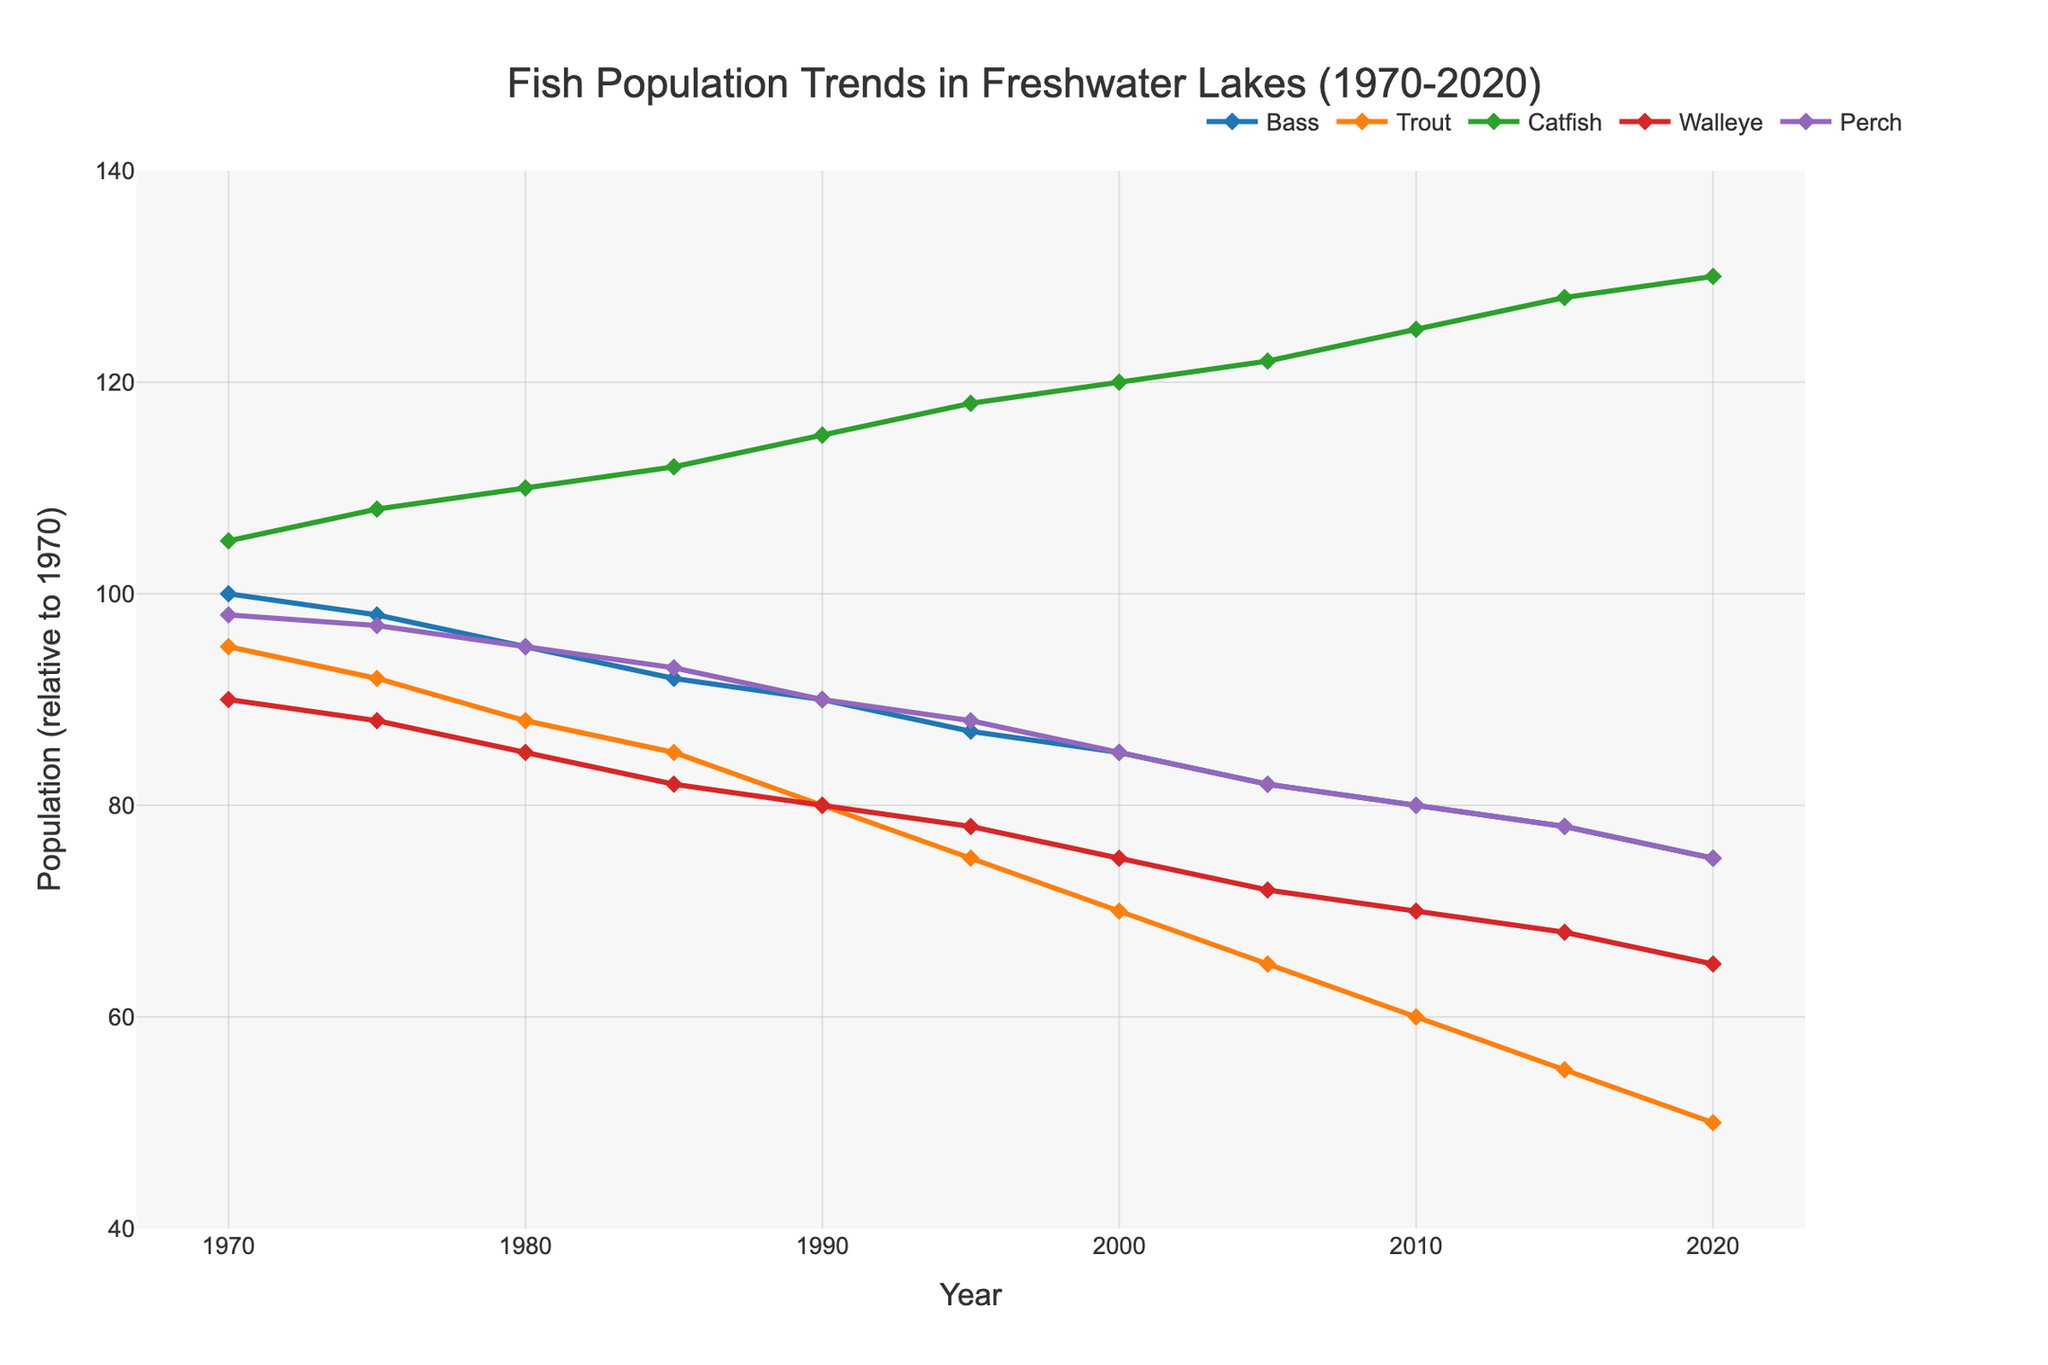How has the Bass population trend changed from 1970 to 2020? The figure shows a line representing the Bass population over the years. From 1970 to 2020, the line declines from 100 to 75. Thus, the Bass population has decreased by 25 units over the 50 years shown.
Answer: Decreased by 25 Which fish species had the smallest population in 2020? The lines on the figure show the populations for all fish species in 2020. Trout had the smallest population with a count of 50.
Answer: Trout Between 1970 and 2020, which fish species exhibited the greatest increase in population? By inspecting the trends for each fish species, Catfish increased from 105 to 130, marking the largest increase of 25 units.
Answer: Catfish Comparing Bass and Trout populations in 1990, which was higher and by how much? The figure shows that in 1990, the Bass population was 90, and the Trout population was 80. The difference is 90 - 80 = 10.
Answer: Bass by 10 What is the ratio of Walleye to Perch population in 2020? From the figure, in 2020, the Walleye population is 65, and the Perch population is 75. The ratio is 65/75.
Answer: 13/15 What was the average population of Catfish from 1980 to 1990? The Catfish population in 1980, 1985, and 1990 are 110, 112, and 115, respectively. The average is calculated as (110 + 112 + 115) / 3 = 112.33.
Answer: 112.33 By how much did the Perch population change from 1970 to 2000? In 1970, the Perch population was 98, and in 2000, it was 85. Therefore, the change is 98 - 85 = 13.
Answer: Decreased by 13 Among all species, which ones experienced a consistent decline in population over the 50 years? By observing the trends from 1970 to 2020, both the Bass and Trout populations consistently declined over the years.
Answer: Bass and Trout During which decade did the Trout population experience the steepest decline? The Trout population dropped from 75 in 1995 to 70 in 2000, a decrease of 5 units in that period, indicating the steepest decline.
Answer: 1990-2000 Rank the fish species based on their population levels in 2010 from highest to lowest. In 2010, the populations were Catfish (125), Bass (80), Walleye (70), Perch (80), and Trout (60). Sorting these from highest to lowest gives: Catfish, Bass, Perch, Walleye, and Trout.
Answer: Catfish, Bass, Perch, Walleye, Trout 